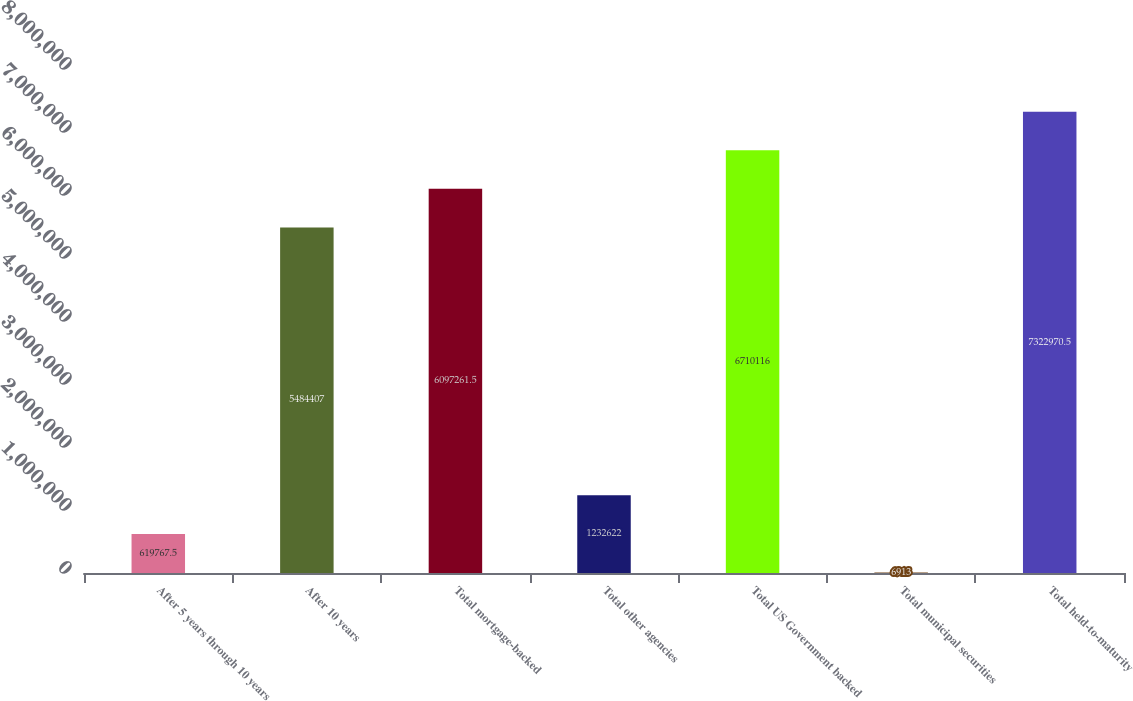Convert chart. <chart><loc_0><loc_0><loc_500><loc_500><bar_chart><fcel>After 5 years through 10 years<fcel>After 10 years<fcel>Total mortgage-backed<fcel>Total other agencies<fcel>Total US Government backed<fcel>Total municipal securities<fcel>Total held-to-maturity<nl><fcel>619768<fcel>5.48441e+06<fcel>6.09726e+06<fcel>1.23262e+06<fcel>6.71012e+06<fcel>6913<fcel>7.32297e+06<nl></chart> 